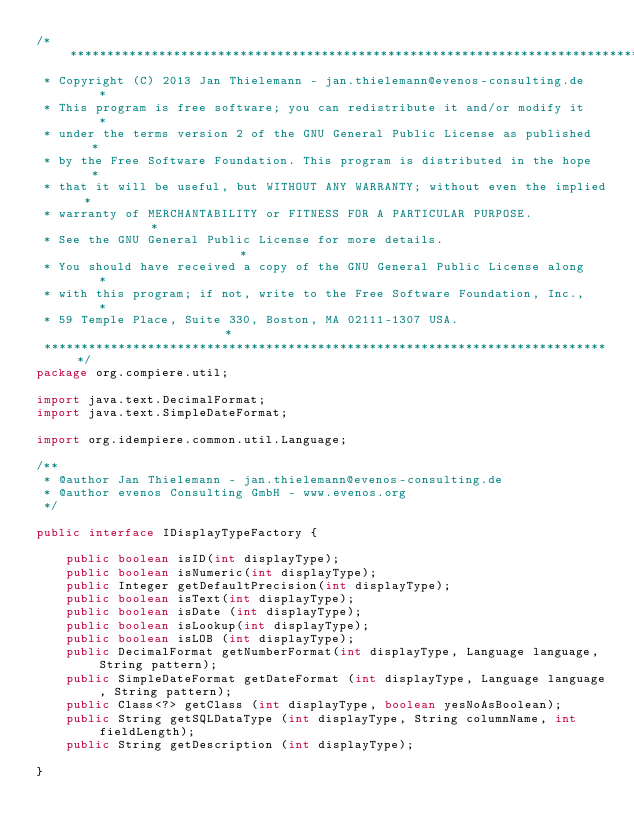Convert code to text. <code><loc_0><loc_0><loc_500><loc_500><_Java_>/******************************************************************************
 * Copyright (C) 2013 Jan Thielemann - jan.thielemann@evenos-consulting.de    *
 * This program is free software; you can redistribute it and/or modify it    *
 * under the terms version 2 of the GNU General Public License as published   *
 * by the Free Software Foundation. This program is distributed in the hope   *
 * that it will be useful, but WITHOUT ANY WARRANTY; without even the implied *
 * warranty of MERCHANTABILITY or FITNESS FOR A PARTICULAR PURPOSE.           *
 * See the GNU General Public License for more details.                       *
 * You should have received a copy of the GNU General Public License along    *
 * with this program; if not, write to the Free Software Foundation, Inc.,    *
 * 59 Temple Place, Suite 330, Boston, MA 02111-1307 USA.                     *
 *****************************************************************************/
package org.compiere.util;

import java.text.DecimalFormat;
import java.text.SimpleDateFormat;

import org.idempiere.common.util.Language;

/**
 * @author Jan Thielemann - jan.thielemann@evenos-consulting.de
 * @author evenos Consulting GmbH - www.evenos.org
 */

public interface IDisplayTypeFactory {
	
	public boolean isID(int displayType);
	public boolean isNumeric(int displayType);
	public Integer getDefaultPrecision(int displayType);
	public boolean isText(int displayType);
	public boolean isDate (int displayType);
	public boolean isLookup(int displayType);
	public boolean isLOB (int displayType);
	public DecimalFormat getNumberFormat(int displayType, Language language, String pattern);
	public SimpleDateFormat getDateFormat (int displayType, Language language, String pattern);
	public Class<?> getClass (int displayType, boolean yesNoAsBoolean);
	public String getSQLDataType (int displayType, String columnName, int fieldLength);
	public String getDescription (int displayType);

}











</code> 